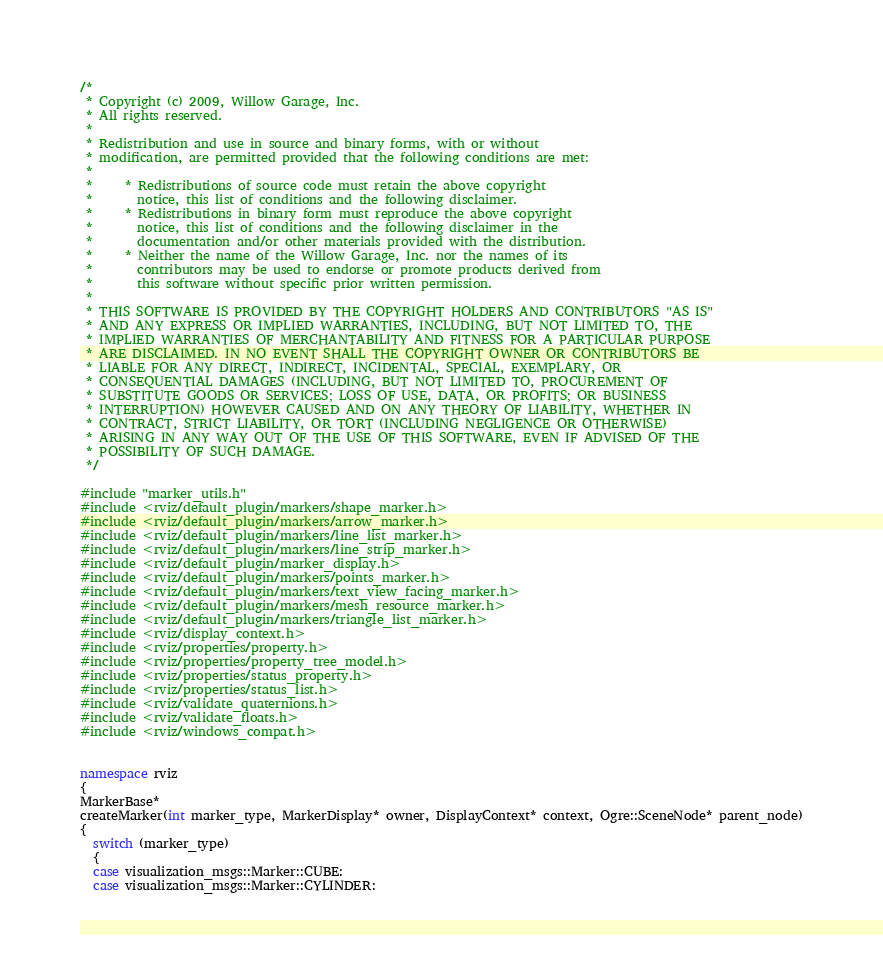<code> <loc_0><loc_0><loc_500><loc_500><_C++_>/*
 * Copyright (c) 2009, Willow Garage, Inc.
 * All rights reserved.
 *
 * Redistribution and use in source and binary forms, with or without
 * modification, are permitted provided that the following conditions are met:
 *
 *     * Redistributions of source code must retain the above copyright
 *       notice, this list of conditions and the following disclaimer.
 *     * Redistributions in binary form must reproduce the above copyright
 *       notice, this list of conditions and the following disclaimer in the
 *       documentation and/or other materials provided with the distribution.
 *     * Neither the name of the Willow Garage, Inc. nor the names of its
 *       contributors may be used to endorse or promote products derived from
 *       this software without specific prior written permission.
 *
 * THIS SOFTWARE IS PROVIDED BY THE COPYRIGHT HOLDERS AND CONTRIBUTORS "AS IS"
 * AND ANY EXPRESS OR IMPLIED WARRANTIES, INCLUDING, BUT NOT LIMITED TO, THE
 * IMPLIED WARRANTIES OF MERCHANTABILITY AND FITNESS FOR A PARTICULAR PURPOSE
 * ARE DISCLAIMED. IN NO EVENT SHALL THE COPYRIGHT OWNER OR CONTRIBUTORS BE
 * LIABLE FOR ANY DIRECT, INDIRECT, INCIDENTAL, SPECIAL, EXEMPLARY, OR
 * CONSEQUENTIAL DAMAGES (INCLUDING, BUT NOT LIMITED TO, PROCUREMENT OF
 * SUBSTITUTE GOODS OR SERVICES; LOSS OF USE, DATA, OR PROFITS; OR BUSINESS
 * INTERRUPTION) HOWEVER CAUSED AND ON ANY THEORY OF LIABILITY, WHETHER IN
 * CONTRACT, STRICT LIABILITY, OR TORT (INCLUDING NEGLIGENCE OR OTHERWISE)
 * ARISING IN ANY WAY OUT OF THE USE OF THIS SOFTWARE, EVEN IF ADVISED OF THE
 * POSSIBILITY OF SUCH DAMAGE.
 */

#include "marker_utils.h"
#include <rviz/default_plugin/markers/shape_marker.h>
#include <rviz/default_plugin/markers/arrow_marker.h>
#include <rviz/default_plugin/markers/line_list_marker.h>
#include <rviz/default_plugin/markers/line_strip_marker.h>
#include <rviz/default_plugin/marker_display.h>
#include <rviz/default_plugin/markers/points_marker.h>
#include <rviz/default_plugin/markers/text_view_facing_marker.h>
#include <rviz/default_plugin/markers/mesh_resource_marker.h>
#include <rviz/default_plugin/markers/triangle_list_marker.h>
#include <rviz/display_context.h>
#include <rviz/properties/property.h>
#include <rviz/properties/property_tree_model.h>
#include <rviz/properties/status_property.h>
#include <rviz/properties/status_list.h>
#include <rviz/validate_quaternions.h>
#include <rviz/validate_floats.h>
#include <rviz/windows_compat.h>


namespace rviz
{
MarkerBase*
createMarker(int marker_type, MarkerDisplay* owner, DisplayContext* context, Ogre::SceneNode* parent_node)
{
  switch (marker_type)
  {
  case visualization_msgs::Marker::CUBE:
  case visualization_msgs::Marker::CYLINDER:</code> 